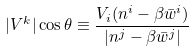<formula> <loc_0><loc_0><loc_500><loc_500>| V ^ { k } | \cos \theta \equiv \frac { V _ { i } ( n ^ { i } - \beta \bar { w } ^ { i } ) } { | n ^ { j } - \beta \bar { w } ^ { j } | }</formula> 